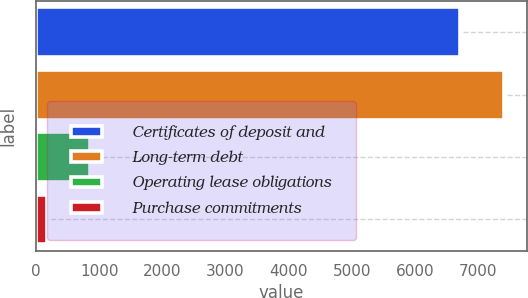Convert chart. <chart><loc_0><loc_0><loc_500><loc_500><bar_chart><fcel>Certificates of deposit and<fcel>Long-term debt<fcel>Operating lease obligations<fcel>Purchase commitments<nl><fcel>6722<fcel>7406.6<fcel>860.6<fcel>176<nl></chart> 